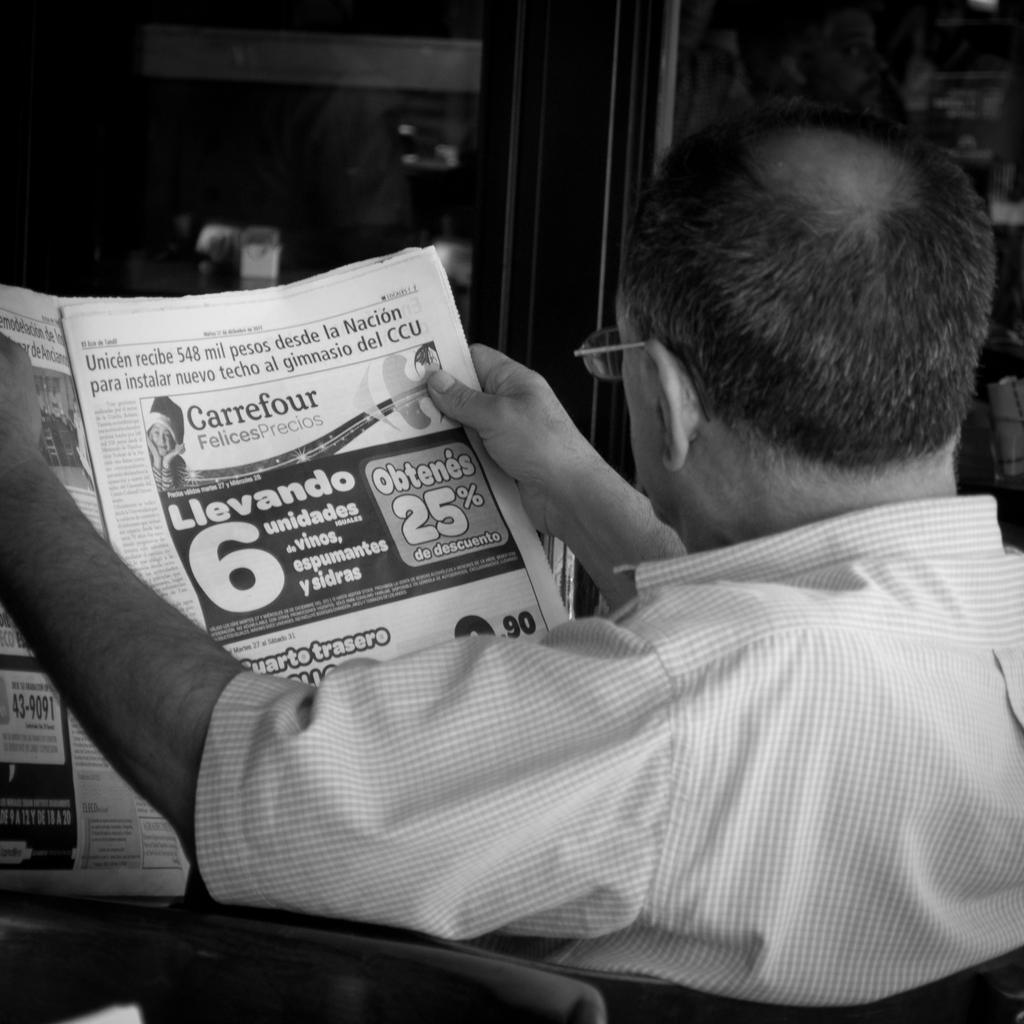What is the person in the image doing? The person is holding a newspaper. What is the person sitting on in the image? The person is sitting on a chair. Can you describe the person's activity in the image? The person is reading the newspaper while sitting on a chair. What type of bomb can be seen in the image? There is no bomb present in the image; it features a person holding a newspaper and sitting on a chair. 